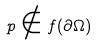Convert formula to latex. <formula><loc_0><loc_0><loc_500><loc_500>p \notin f ( \partial \Omega )</formula> 